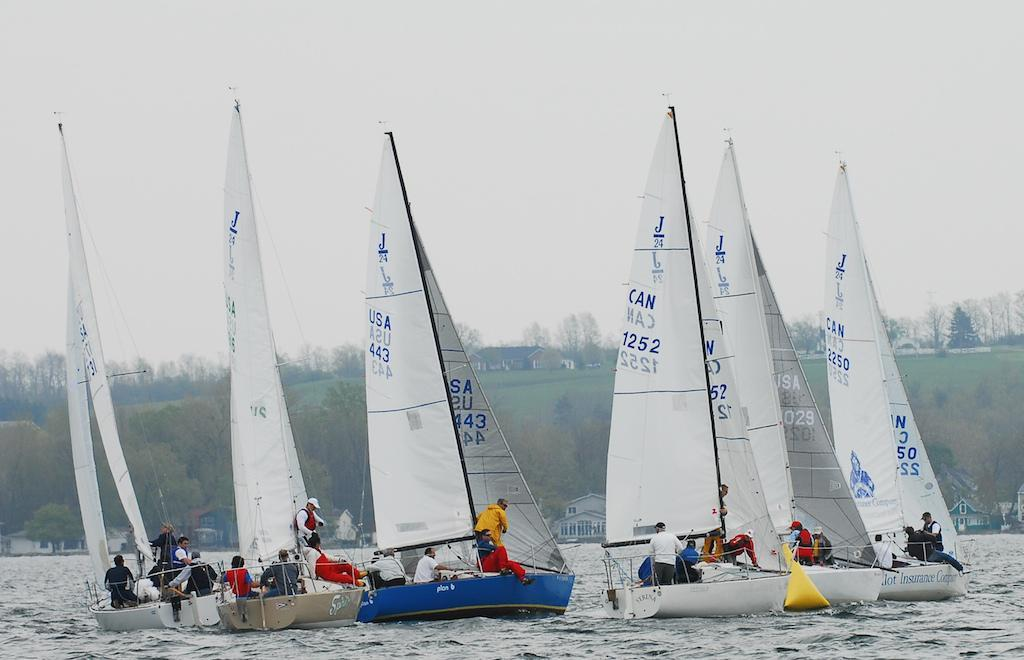Provide a one-sentence caption for the provided image. A group of sailboats compete at a regatta, and the blue sailboat is from the USA and numbered 443 on the sail. 